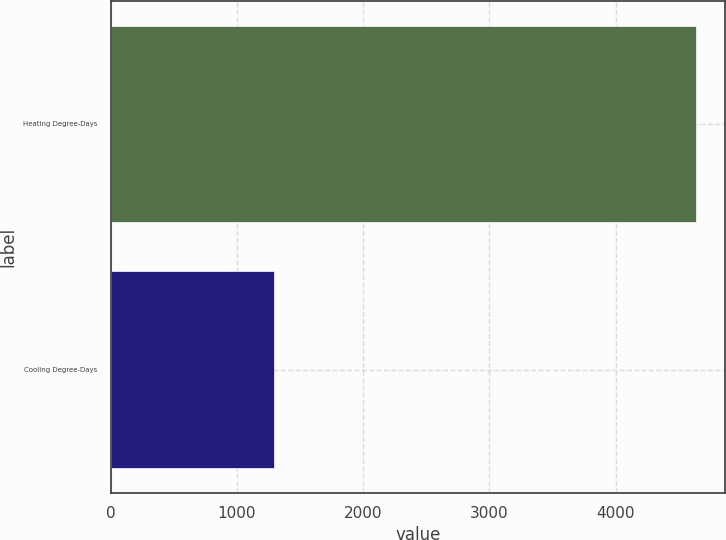<chart> <loc_0><loc_0><loc_500><loc_500><bar_chart><fcel>Heating Degree-Days<fcel>Cooling Degree-Days<nl><fcel>4638<fcel>1292<nl></chart> 